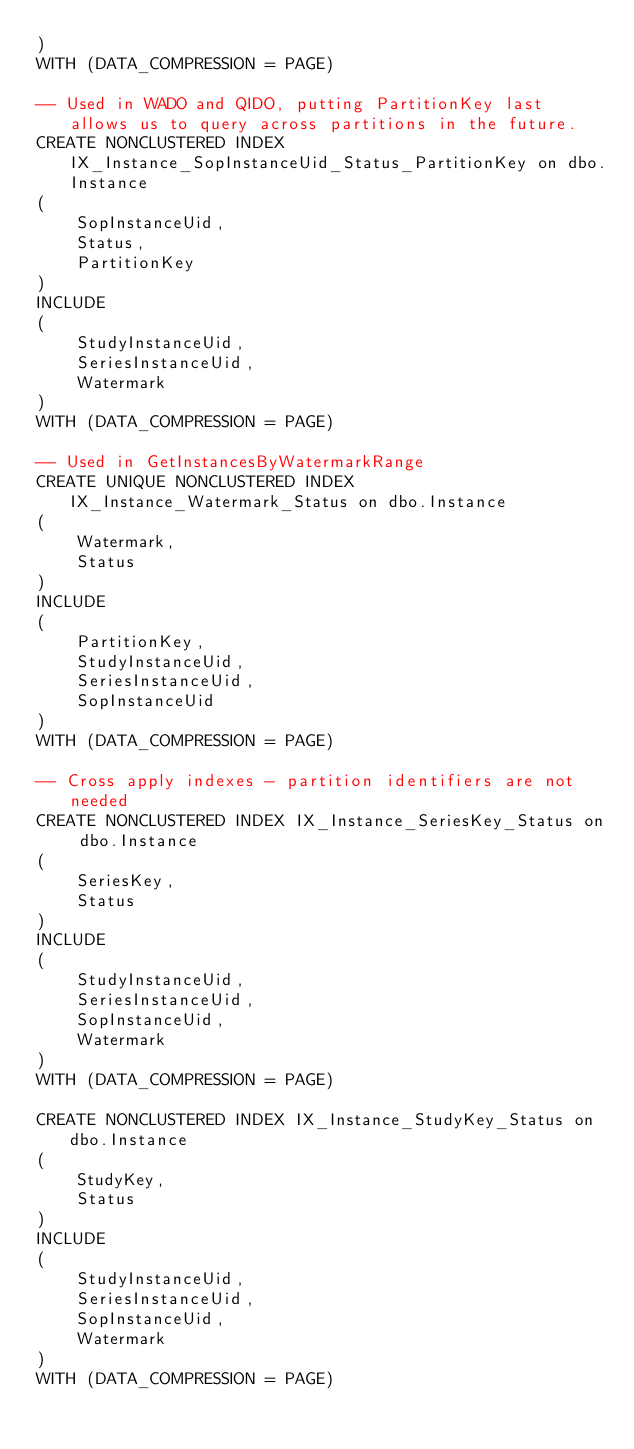Convert code to text. <code><loc_0><loc_0><loc_500><loc_500><_SQL_>)
WITH (DATA_COMPRESSION = PAGE)

-- Used in WADO and QIDO, putting PartitionKey last allows us to query across partitions in the future.
CREATE NONCLUSTERED INDEX IX_Instance_SopInstanceUid_Status_PartitionKey on dbo.Instance
(
    SopInstanceUid,
    Status,
    PartitionKey    
)
INCLUDE
(
    StudyInstanceUid,
    SeriesInstanceUid,
    Watermark
)
WITH (DATA_COMPRESSION = PAGE)

-- Used in GetInstancesByWatermarkRange
CREATE UNIQUE NONCLUSTERED INDEX IX_Instance_Watermark_Status on dbo.Instance
(
    Watermark,
    Status
)
INCLUDE
(
    PartitionKey,
    StudyInstanceUid,
    SeriesInstanceUid,
    SopInstanceUid
)
WITH (DATA_COMPRESSION = PAGE)

-- Cross apply indexes - partition identifiers are not needed
CREATE NONCLUSTERED INDEX IX_Instance_SeriesKey_Status on dbo.Instance
(
    SeriesKey,
    Status
)
INCLUDE
(
    StudyInstanceUid,
    SeriesInstanceUid,
    SopInstanceUid,
    Watermark
)
WITH (DATA_COMPRESSION = PAGE)

CREATE NONCLUSTERED INDEX IX_Instance_StudyKey_Status on dbo.Instance
(
    StudyKey,
    Status
)
INCLUDE
(
    StudyInstanceUid,
    SeriesInstanceUid,
    SopInstanceUid,
    Watermark
)
WITH (DATA_COMPRESSION = PAGE)
</code> 